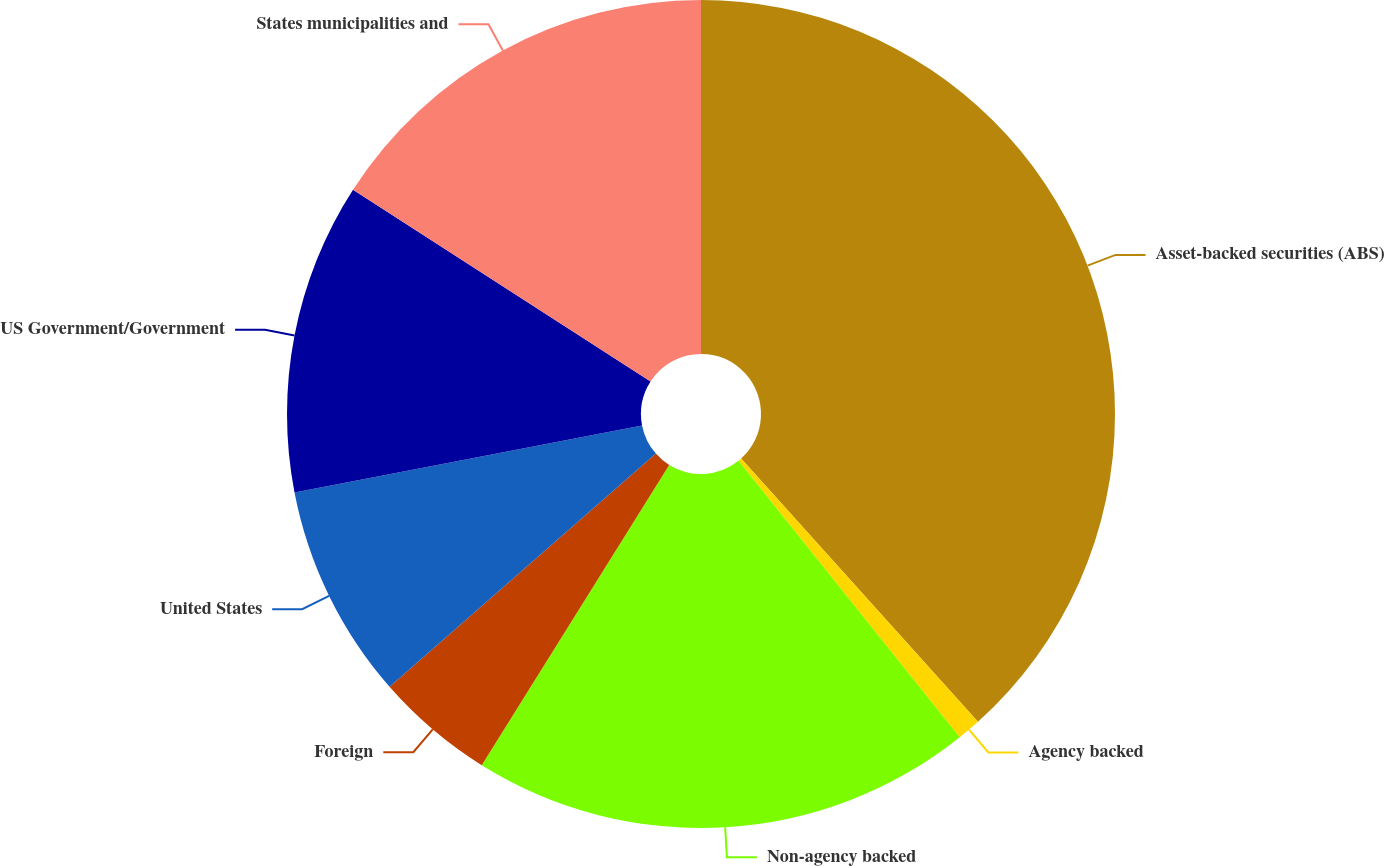<chart> <loc_0><loc_0><loc_500><loc_500><pie_chart><fcel>Asset-backed securities (ABS)<fcel>Agency backed<fcel>Non-agency backed<fcel>Foreign<fcel>United States<fcel>US Government/Government<fcel>States municipalities and<nl><fcel>38.34%<fcel>0.92%<fcel>19.63%<fcel>4.67%<fcel>8.41%<fcel>12.15%<fcel>15.89%<nl></chart> 